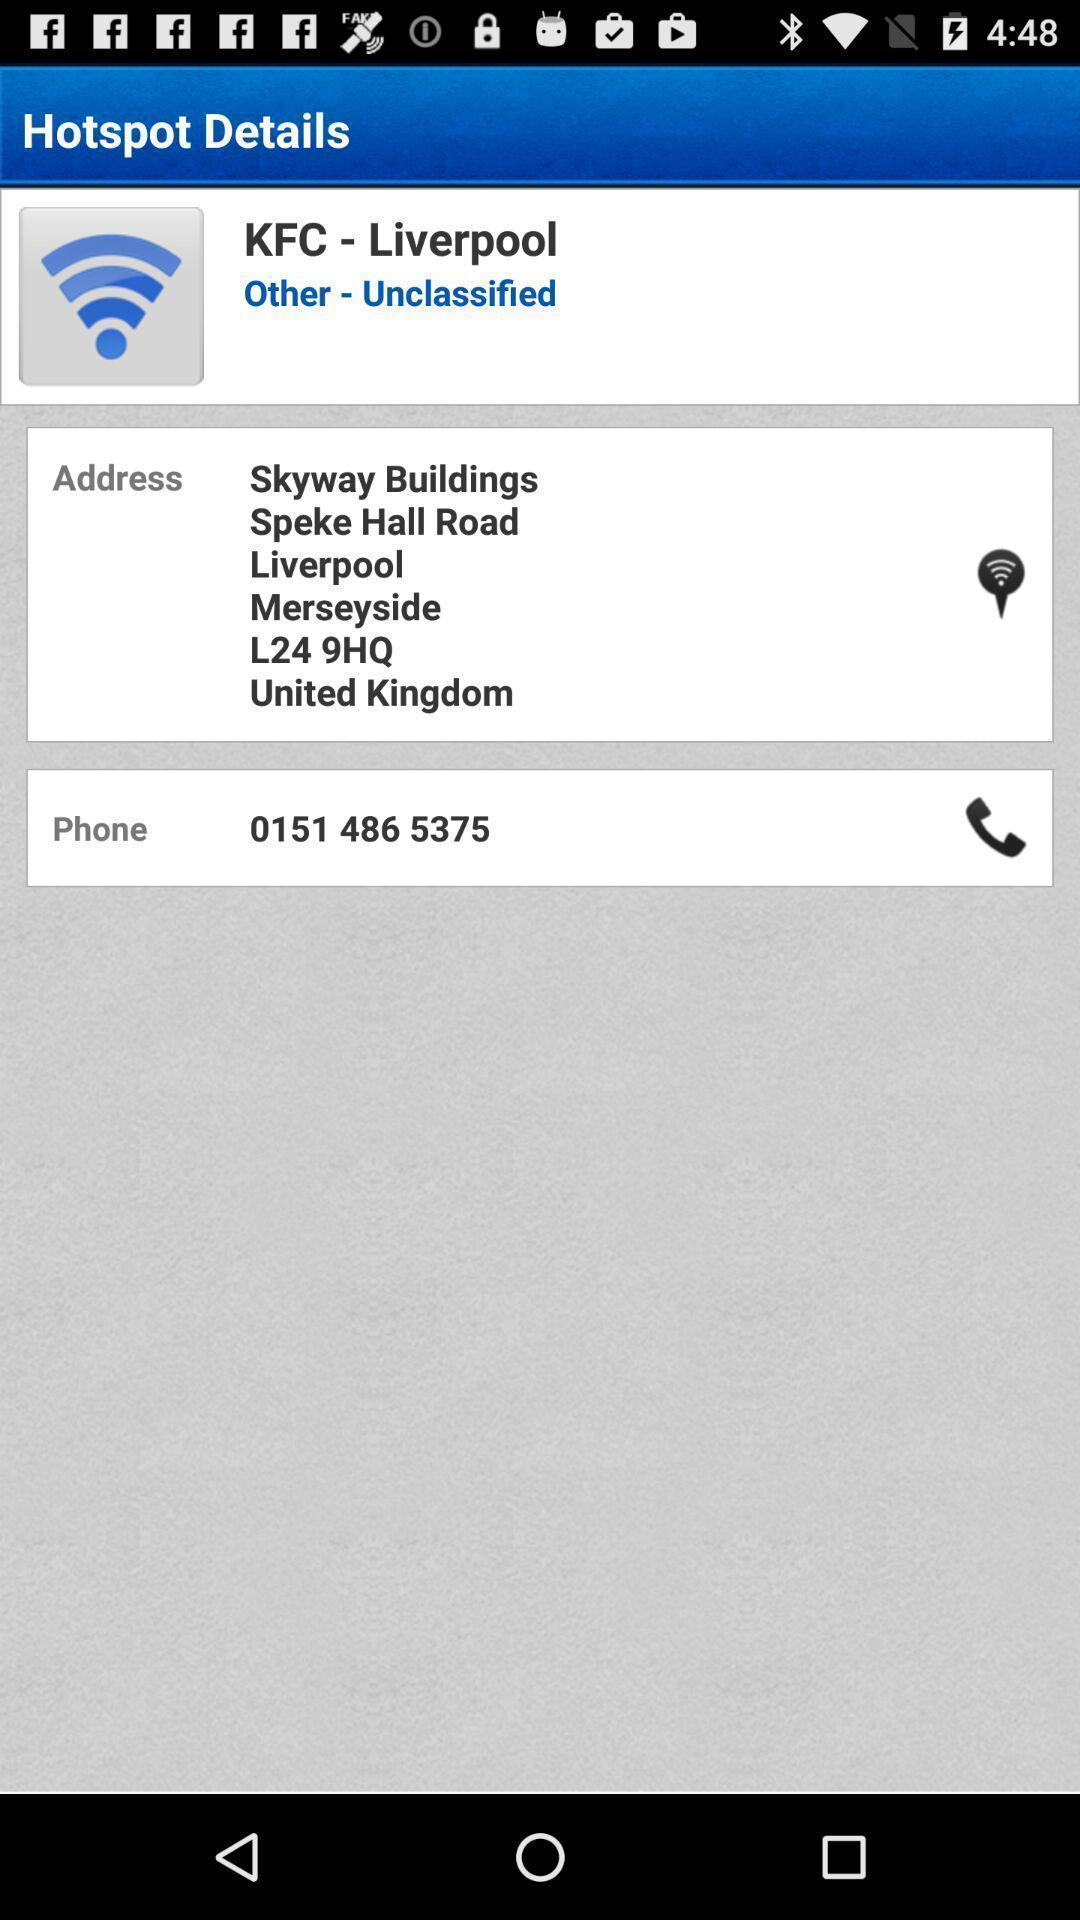Explain the elements present in this screenshot. Page showing the details of hotspot. 